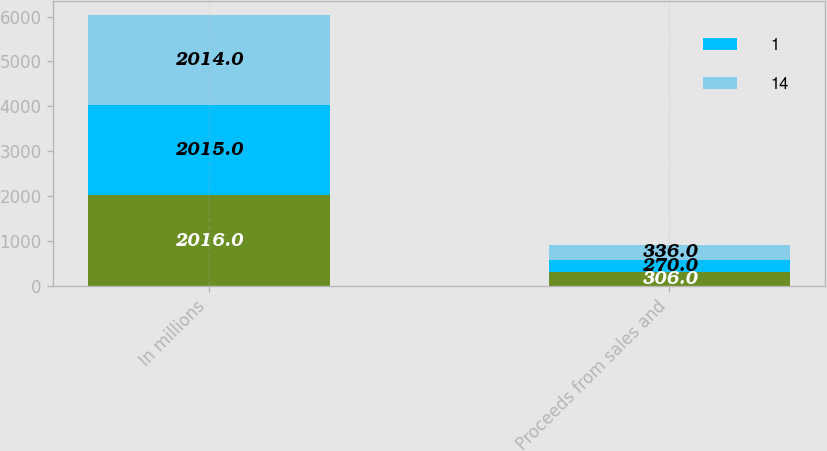Convert chart to OTSL. <chart><loc_0><loc_0><loc_500><loc_500><stacked_bar_chart><ecel><fcel>In millions<fcel>Proceeds from sales and<nl><fcel>nan<fcel>2016<fcel>306<nl><fcel>1<fcel>2015<fcel>270<nl><fcel>14<fcel>2014<fcel>336<nl></chart> 